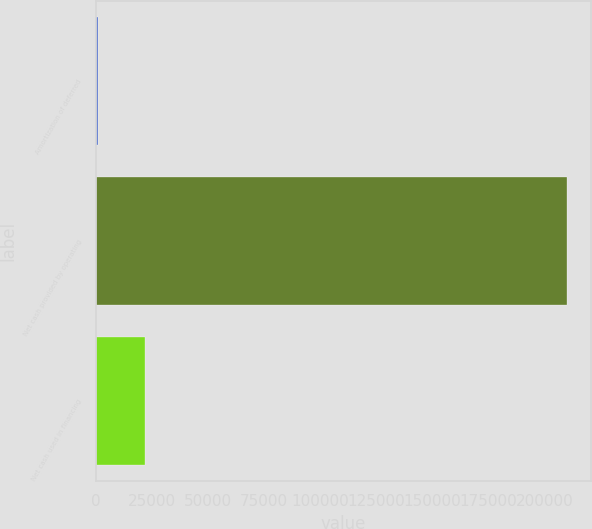Convert chart to OTSL. <chart><loc_0><loc_0><loc_500><loc_500><bar_chart><fcel>Amortization of deferred<fcel>Net cash provided by operating<fcel>Net cash used in financing<nl><fcel>943<fcel>210149<fcel>21863.6<nl></chart> 